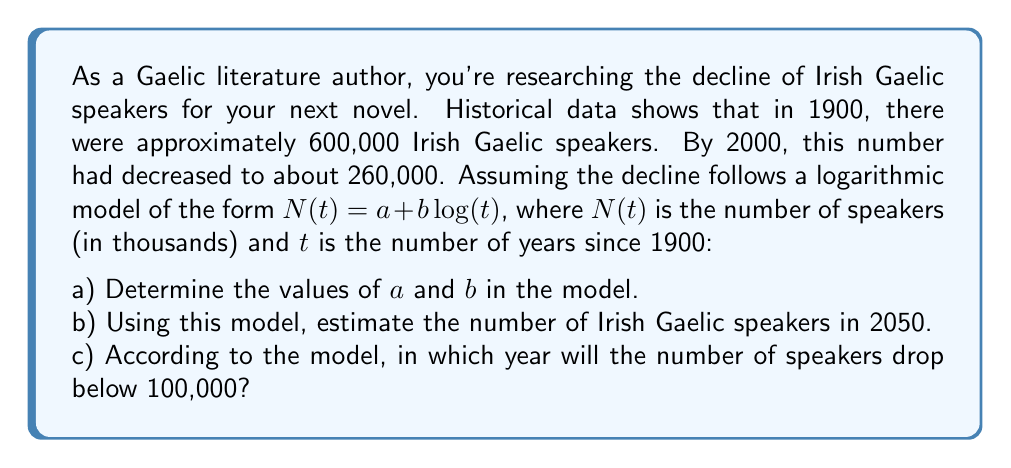Can you solve this math problem? Let's approach this problem step by step:

a) To find $a$ and $b$, we'll use the two data points we have:
   For 1900 (t = 1): $N(1) = 600 = a + b \log(1) = a$ (since $\log(1) = 0$)
   For 2000 (t = 101): $N(101) = 260 = a + b \log(101)$

   Substituting $a = 600$ into the second equation:
   $260 = 600 + b \log(101)$
   $b \log(101) = -340$
   $b = \frac{-340}{\log(101)} \approx -166.76$

   Therefore, our model is: $N(t) = 600 - 166.76 \log(t)$

b) To estimate the number of speakers in 2050, we calculate t = 2050 - 1900 + 1 = 151:

   $N(151) = 600 - 166.76 \log(151) \approx 188.5$ thousand

c) To find when the number drops below 100,000, we solve:
   $100 = 600 - 166.76 \log(t)$
   $\frac{500}{166.76} = \log(t)$
   $t = e^{\frac{500}{166.76}} \approx 20.37$

   Adding this to 1900, we get approximately the year 1920.37. However, since our model is based on data from 1900-2000, extrapolating backwards isn't reliable. The model suggests the number would have dropped below 100,000 before 1900, which contradicts our initial data point.
Answer: a) $a = 600$, $b \approx -166.76$
b) Approximately 188,500 speakers in 2050
c) The model incorrectly suggests before 1900, indicating limitations in backward extrapolation 